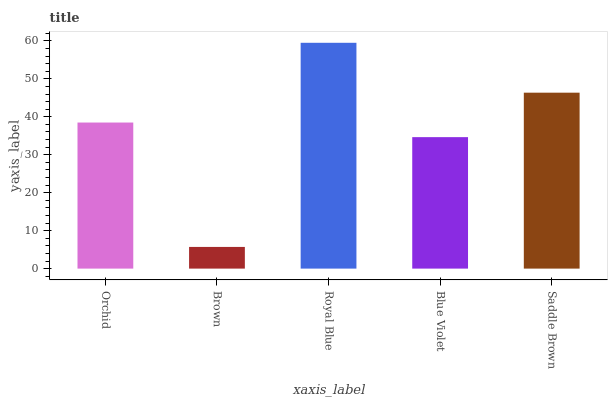Is Brown the minimum?
Answer yes or no. Yes. Is Royal Blue the maximum?
Answer yes or no. Yes. Is Royal Blue the minimum?
Answer yes or no. No. Is Brown the maximum?
Answer yes or no. No. Is Royal Blue greater than Brown?
Answer yes or no. Yes. Is Brown less than Royal Blue?
Answer yes or no. Yes. Is Brown greater than Royal Blue?
Answer yes or no. No. Is Royal Blue less than Brown?
Answer yes or no. No. Is Orchid the high median?
Answer yes or no. Yes. Is Orchid the low median?
Answer yes or no. Yes. Is Saddle Brown the high median?
Answer yes or no. No. Is Blue Violet the low median?
Answer yes or no. No. 